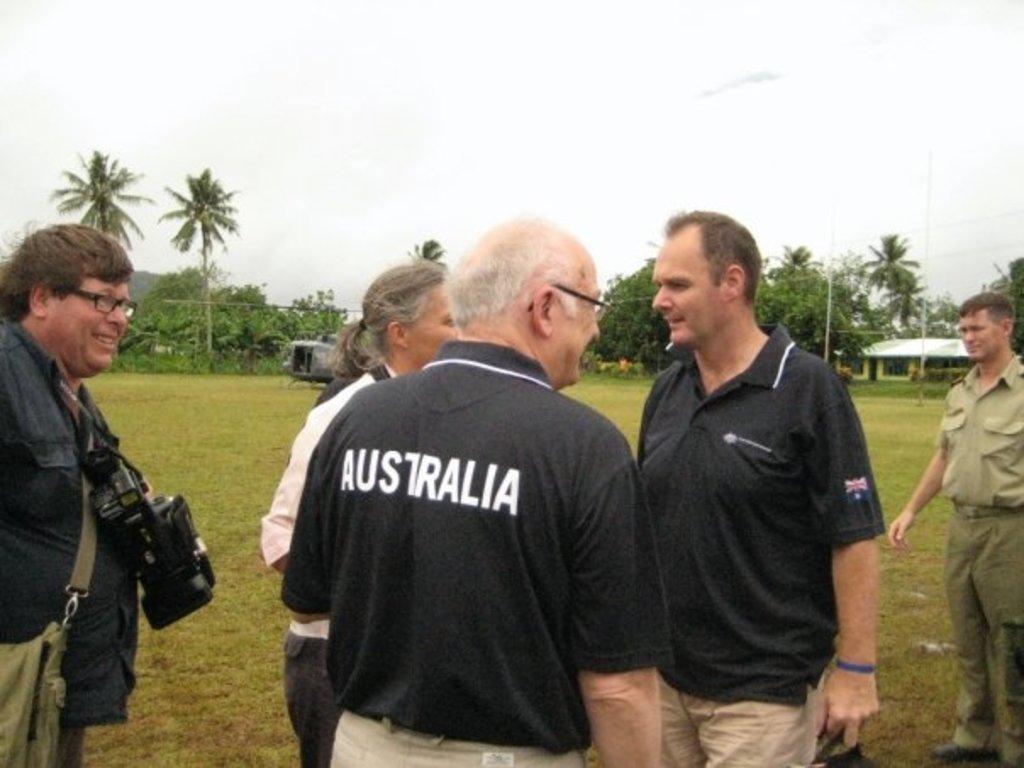Describe this image in one or two sentences. In the middle an old man is standing, he wore a black color t-shirt with a name Australia on it. In front of him a woman is also standing, few other persons are there in this image. At the back side there are trees, at the top it is the sky. 